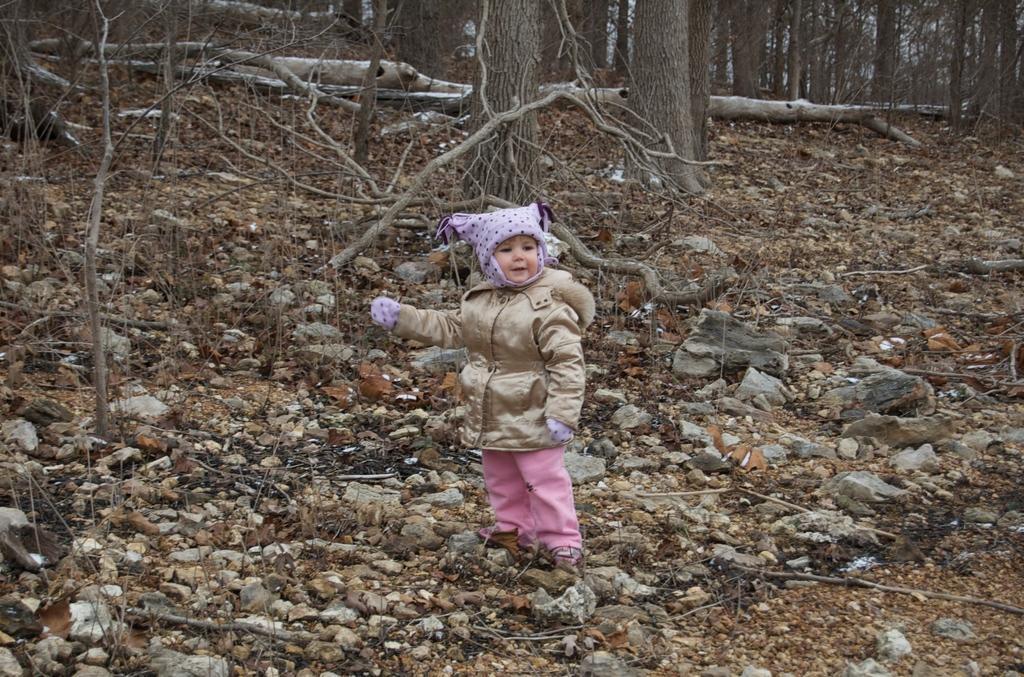Describe this image in one or two sentences. In this image I can see a kid. In the background, I can see the stones and the trees. 